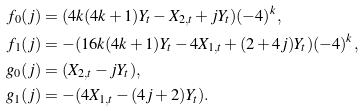<formula> <loc_0><loc_0><loc_500><loc_500>f _ { 0 } ( j ) & = ( 4 k ( 4 k + 1 ) Y _ { t } - X _ { 2 , t } + j Y _ { t } ) ( - 4 ) ^ { k } , \\ f _ { 1 } ( j ) & = - ( 1 6 k ( 4 k + 1 ) Y _ { t } - 4 X _ { 1 , t } + ( 2 + 4 j ) Y _ { t } ) ( - 4 ) ^ { k } , \\ g _ { 0 } ( j ) & = ( X _ { 2 , t } - j Y _ { t } ) , \\ g _ { 1 } ( j ) & = - ( 4 X _ { 1 , t } - ( 4 j + 2 ) Y _ { t } ) .</formula> 